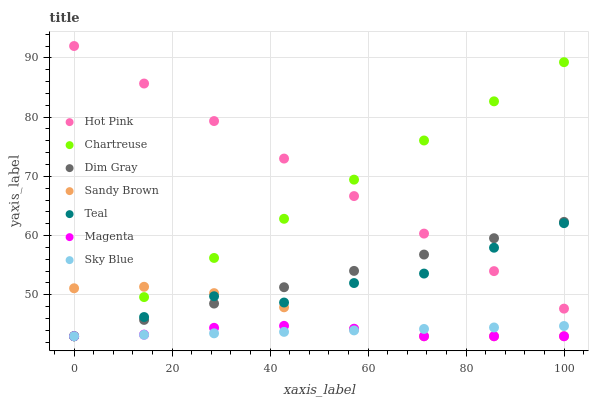Does Magenta have the minimum area under the curve?
Answer yes or no. Yes. Does Hot Pink have the maximum area under the curve?
Answer yes or no. Yes. Does Chartreuse have the minimum area under the curve?
Answer yes or no. No. Does Chartreuse have the maximum area under the curve?
Answer yes or no. No. Is Chartreuse the smoothest?
Answer yes or no. Yes. Is Teal the roughest?
Answer yes or no. Yes. Is Hot Pink the smoothest?
Answer yes or no. No. Is Hot Pink the roughest?
Answer yes or no. No. Does Dim Gray have the lowest value?
Answer yes or no. Yes. Does Hot Pink have the lowest value?
Answer yes or no. No. Does Hot Pink have the highest value?
Answer yes or no. Yes. Does Chartreuse have the highest value?
Answer yes or no. No. Is Sky Blue less than Hot Pink?
Answer yes or no. Yes. Is Hot Pink greater than Sandy Brown?
Answer yes or no. Yes. Does Dim Gray intersect Teal?
Answer yes or no. Yes. Is Dim Gray less than Teal?
Answer yes or no. No. Is Dim Gray greater than Teal?
Answer yes or no. No. Does Sky Blue intersect Hot Pink?
Answer yes or no. No. 